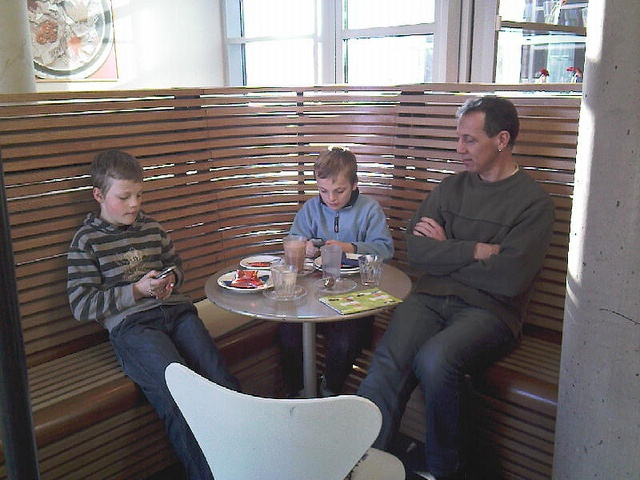Describe the objects in this image and their specific colors. I can see people in gray and black tones, people in gray, black, and darkgray tones, chair in gray, darkgray, lightblue, and lightgray tones, dining table in gray, darkgray, and tan tones, and bench in gray and black tones in this image. 